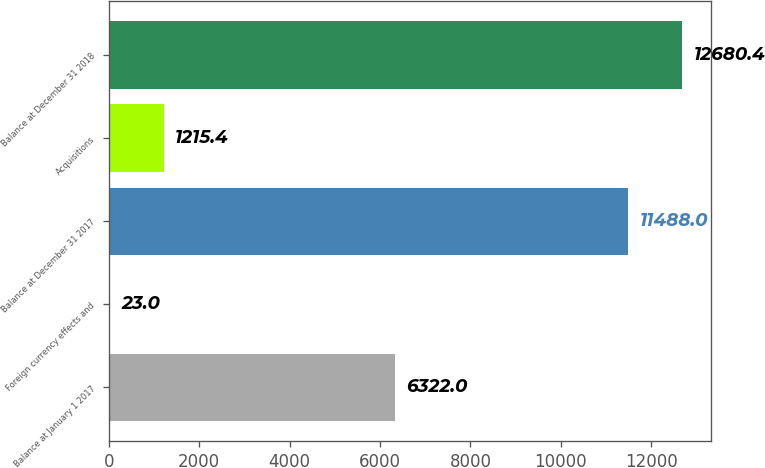Convert chart. <chart><loc_0><loc_0><loc_500><loc_500><bar_chart><fcel>Balance at January 1 2017<fcel>Foreign currency effects and<fcel>Balance at December 31 2017<fcel>Acquisitions<fcel>Balance at December 31 2018<nl><fcel>6322<fcel>23<fcel>11488<fcel>1215.4<fcel>12680.4<nl></chart> 